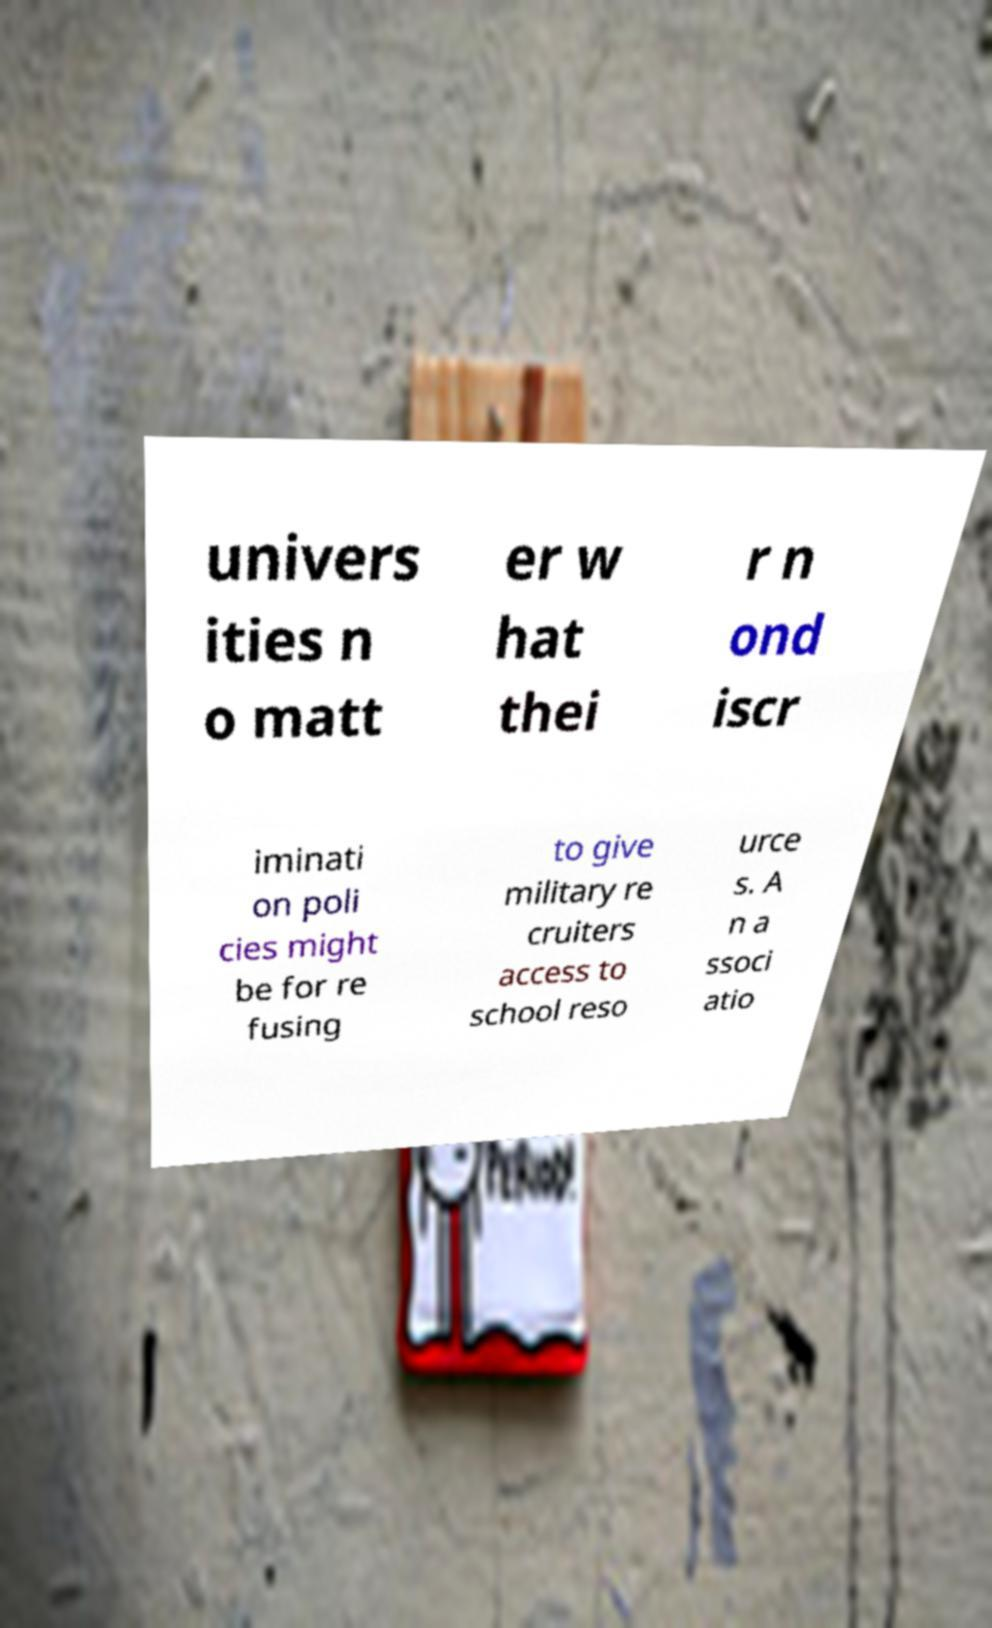I need the written content from this picture converted into text. Can you do that? univers ities n o matt er w hat thei r n ond iscr iminati on poli cies might be for re fusing to give military re cruiters access to school reso urce s. A n a ssoci atio 